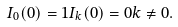Convert formula to latex. <formula><loc_0><loc_0><loc_500><loc_500>I _ { 0 } ( 0 ) = 1 I _ { k } ( 0 ) = 0 k \ne 0 .</formula> 